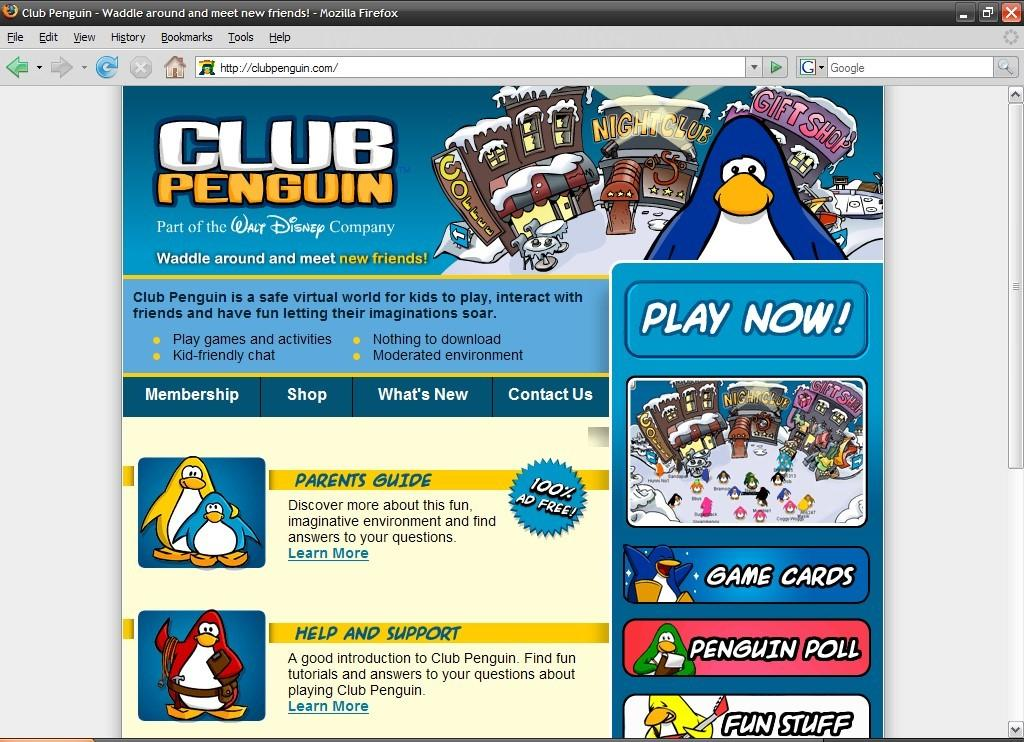What electronic device is visible in the image? There is a computer screen or a tab in the image. What is located in the center of the image? There is a poster in the center of the image. What type of content is on the poster? The poster contains cartoons and text. Where is additional text located in the image? There is text at the top of the image. What type of seed is being planted in the image? There is no seed or planting activity present in the image. How many vegetables are visible in the image? There are no vegetables present in the image. 